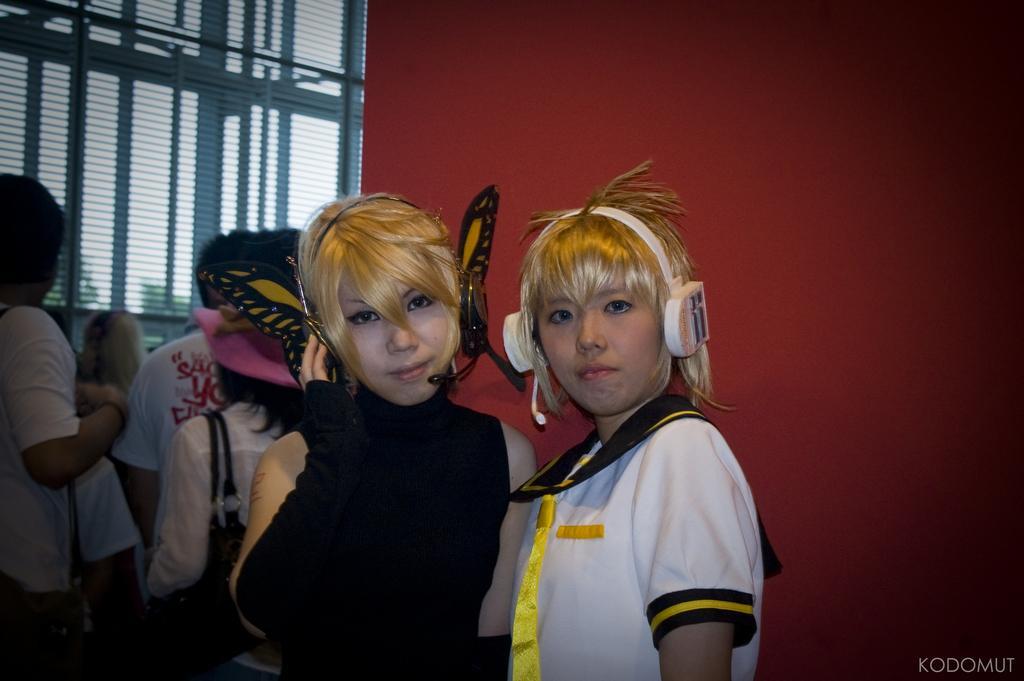Could you give a brief overview of what you see in this image? In this picture we can see two women standing with headsets and in the background we can see some persons, wall. 